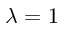<formula> <loc_0><loc_0><loc_500><loc_500>\lambda = 1</formula> 